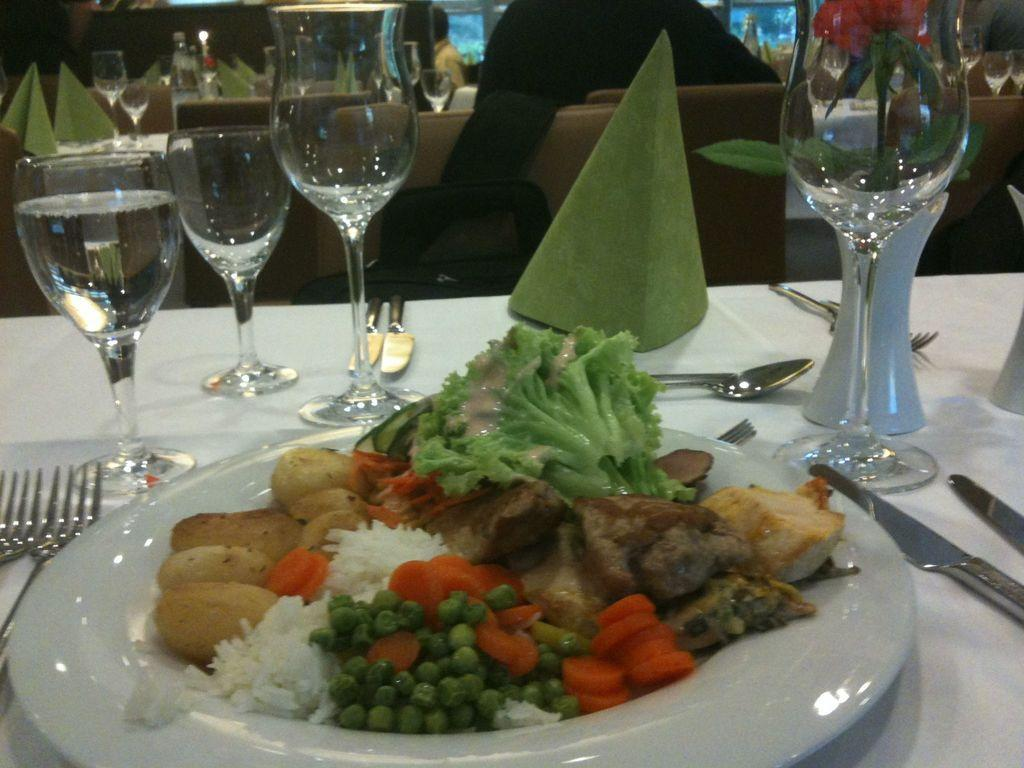What is on the plate that is visible in the image? There is food on a plate in the image. What type of glasses can be seen on the table in the image? There are wine glasses on the table in the image. How does the cake run around the table in the image? There is no cake present in the image, so it cannot run around the table. 